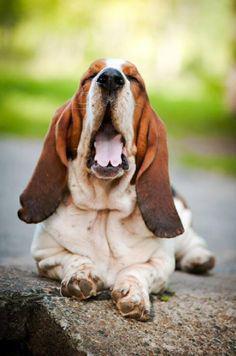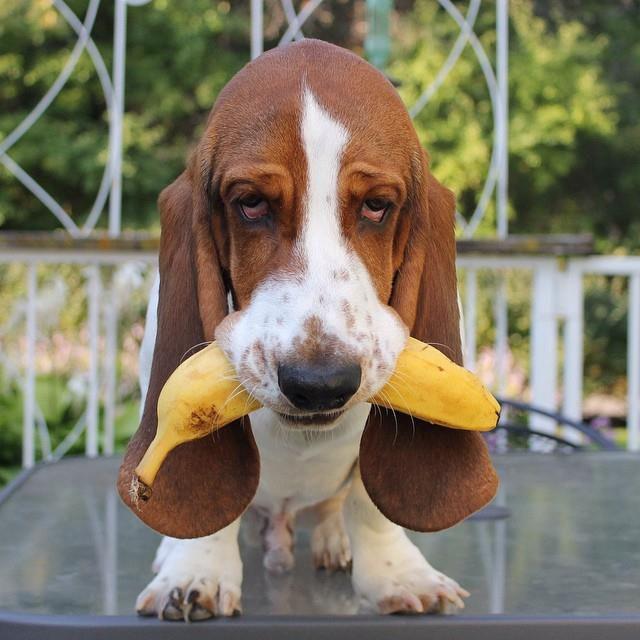The first image is the image on the left, the second image is the image on the right. Evaluate the accuracy of this statement regarding the images: "The dog in the image on the left is sitting on grass.". Is it true? Answer yes or no. No. The first image is the image on the left, the second image is the image on the right. Evaluate the accuracy of this statement regarding the images: "One image shows a basset hound sitting on furniture made for humans.". Is it true? Answer yes or no. No. 